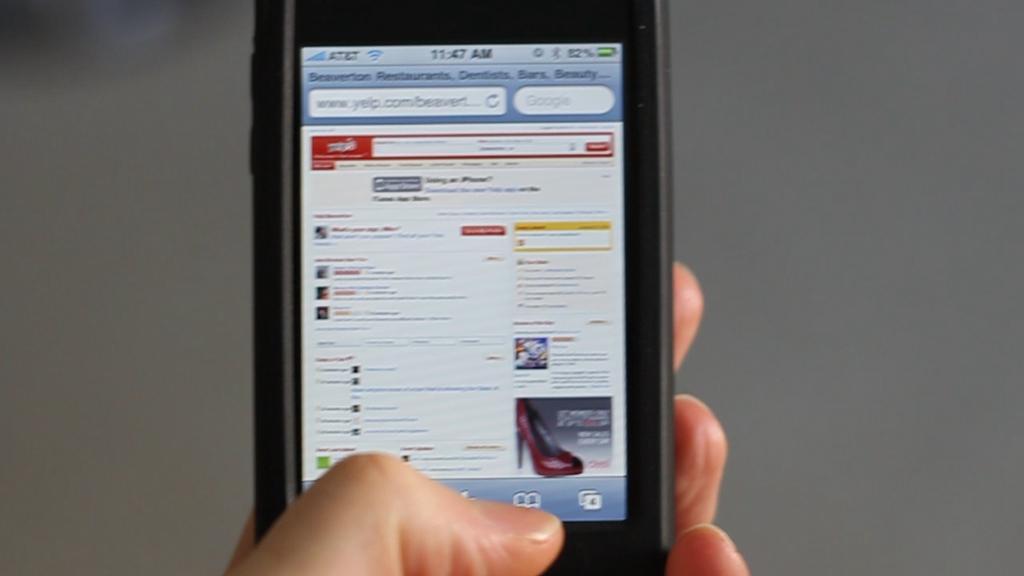Could you give a brief overview of what you see in this image? In this image in the center there is one person who is holding a mobile phone, and in the mobile phone there is text and an image of footwear and there is blurry background. 